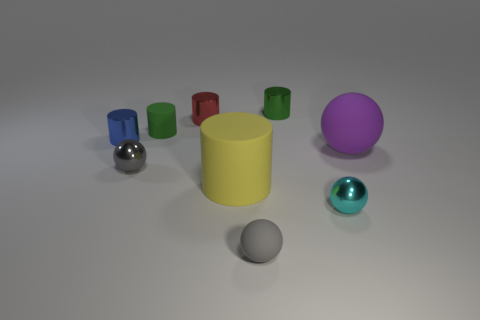Subtract all cyan spheres. How many spheres are left? 3 Subtract all large cylinders. How many cylinders are left? 4 Subtract all purple cylinders. Subtract all green spheres. How many cylinders are left? 5 Add 1 tiny objects. How many objects exist? 10 Subtract all spheres. How many objects are left? 5 Add 7 small gray rubber objects. How many small gray rubber objects are left? 8 Add 5 purple things. How many purple things exist? 6 Subtract 0 blue balls. How many objects are left? 9 Subtract all rubber objects. Subtract all large yellow rubber blocks. How many objects are left? 5 